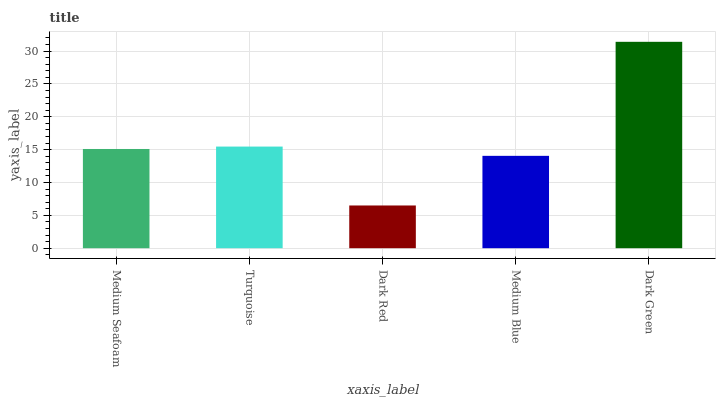Is Turquoise the minimum?
Answer yes or no. No. Is Turquoise the maximum?
Answer yes or no. No. Is Turquoise greater than Medium Seafoam?
Answer yes or no. Yes. Is Medium Seafoam less than Turquoise?
Answer yes or no. Yes. Is Medium Seafoam greater than Turquoise?
Answer yes or no. No. Is Turquoise less than Medium Seafoam?
Answer yes or no. No. Is Medium Seafoam the high median?
Answer yes or no. Yes. Is Medium Seafoam the low median?
Answer yes or no. Yes. Is Dark Red the high median?
Answer yes or no. No. Is Dark Red the low median?
Answer yes or no. No. 